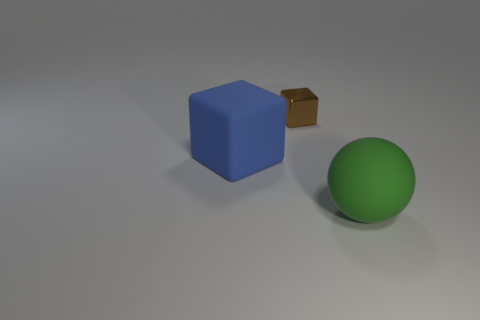Add 2 small yellow rubber cylinders. How many objects exist? 5 Subtract all spheres. How many objects are left? 2 Add 3 brown blocks. How many brown blocks exist? 4 Subtract 0 yellow balls. How many objects are left? 3 Subtract all blue rubber things. Subtract all big rubber things. How many objects are left? 0 Add 1 green balls. How many green balls are left? 2 